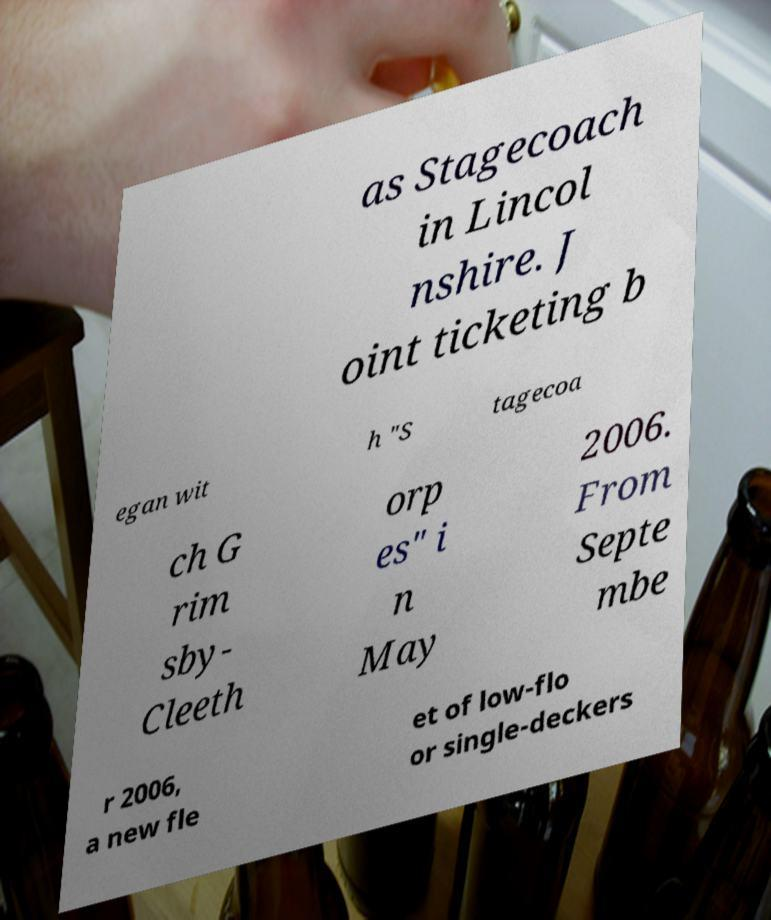Please read and relay the text visible in this image. What does it say? as Stagecoach in Lincol nshire. J oint ticketing b egan wit h "S tagecoa ch G rim sby- Cleeth orp es" i n May 2006. From Septe mbe r 2006, a new fle et of low-flo or single-deckers 